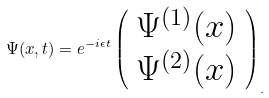<formula> <loc_0><loc_0><loc_500><loc_500>\Psi ( x , t ) = e ^ { - i \epsilon t } \left ( \begin{array} { c } \Psi ^ { ( 1 ) } ( x ) \\ \Psi ^ { ( 2 ) } ( x ) \end{array} \right ) _ { . }</formula> 